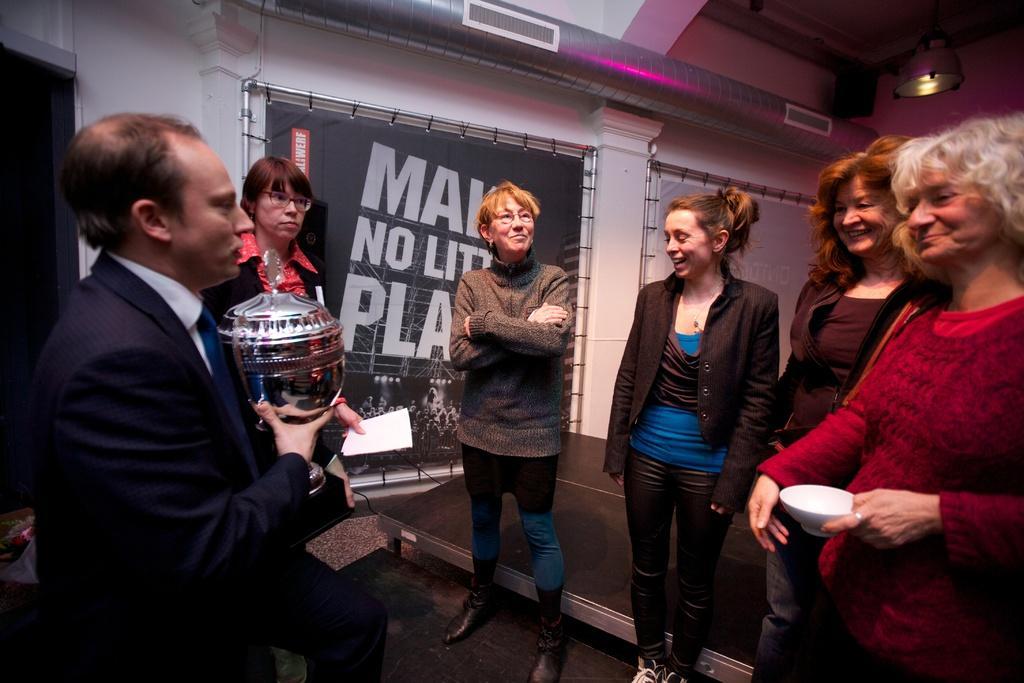Describe this image in one or two sentences. In this image, we can see a group of people. Few are holding some object. Here we can see few people are smiling. Background we can see banners, rods, wall, pipe, light and few things. 